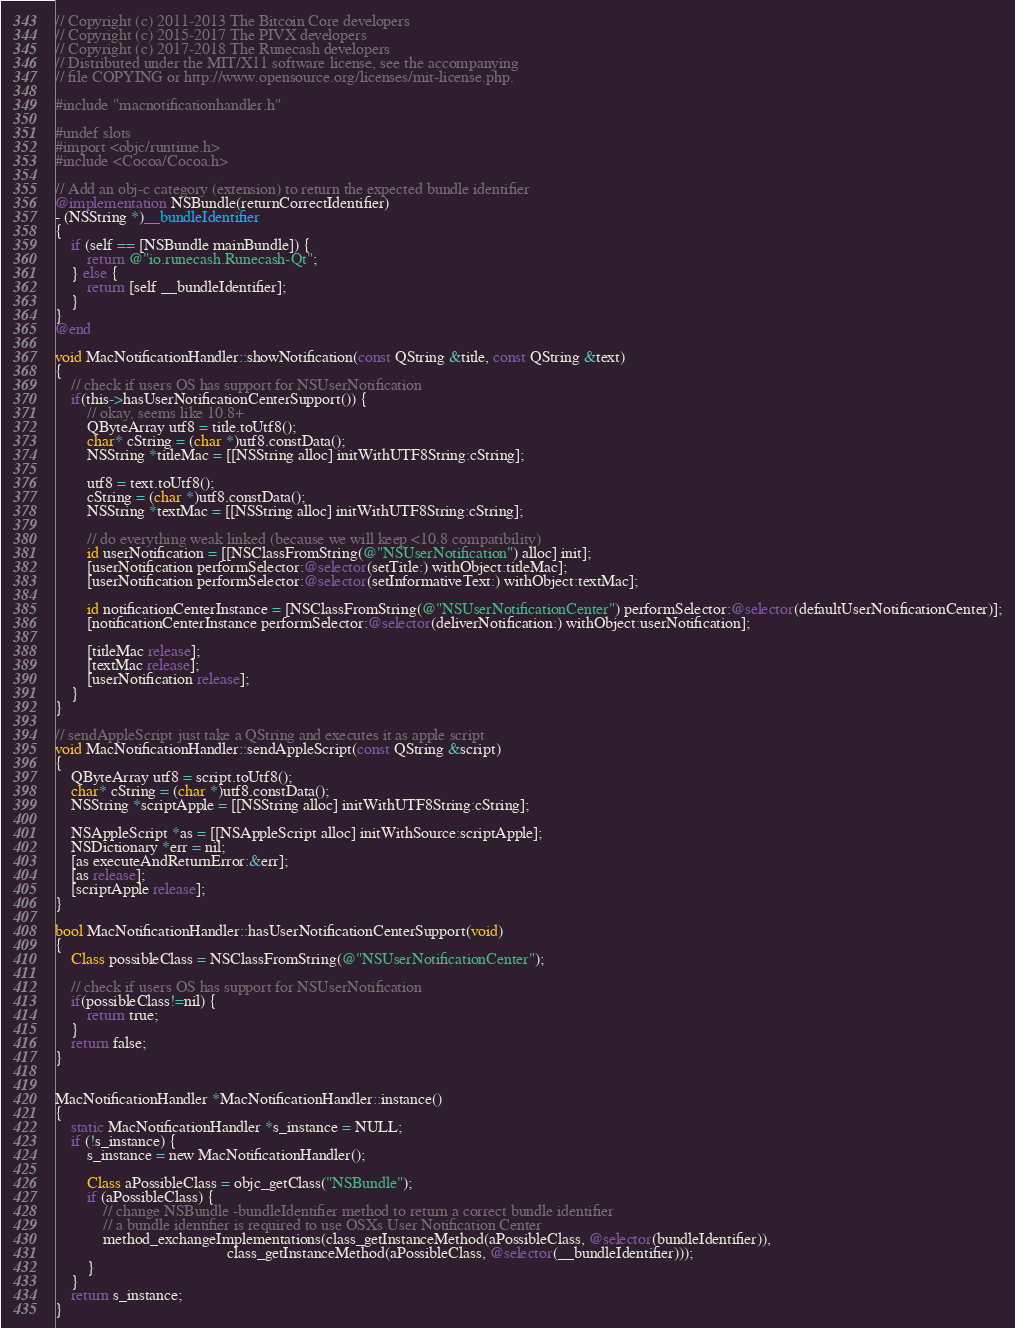<code> <loc_0><loc_0><loc_500><loc_500><_ObjectiveC_>// Copyright (c) 2011-2013 The Bitcoin Core developers
// Copyright (c) 2015-2017 The PIVX developers
// Copyright (c) 2017-2018 The Runecash developers
// Distributed under the MIT/X11 software license, see the accompanying
// file COPYING or http://www.opensource.org/licenses/mit-license.php.

#include "macnotificationhandler.h"

#undef slots
#import <objc/runtime.h>
#include <Cocoa/Cocoa.h>

// Add an obj-c category (extension) to return the expected bundle identifier
@implementation NSBundle(returnCorrectIdentifier)
- (NSString *)__bundleIdentifier
{
    if (self == [NSBundle mainBundle]) {
        return @"io.runecash.Runecash-Qt";
    } else {
        return [self __bundleIdentifier];
    }
}
@end

void MacNotificationHandler::showNotification(const QString &title, const QString &text)
{
    // check if users OS has support for NSUserNotification
    if(this->hasUserNotificationCenterSupport()) {
        // okay, seems like 10.8+
        QByteArray utf8 = title.toUtf8();
        char* cString = (char *)utf8.constData();
        NSString *titleMac = [[NSString alloc] initWithUTF8String:cString];

        utf8 = text.toUtf8();
        cString = (char *)utf8.constData();
        NSString *textMac = [[NSString alloc] initWithUTF8String:cString];

        // do everything weak linked (because we will keep <10.8 compatibility)
        id userNotification = [[NSClassFromString(@"NSUserNotification") alloc] init];
        [userNotification performSelector:@selector(setTitle:) withObject:titleMac];
        [userNotification performSelector:@selector(setInformativeText:) withObject:textMac];

        id notificationCenterInstance = [NSClassFromString(@"NSUserNotificationCenter") performSelector:@selector(defaultUserNotificationCenter)];
        [notificationCenterInstance performSelector:@selector(deliverNotification:) withObject:userNotification];

        [titleMac release];
        [textMac release];
        [userNotification release];
    }
}

// sendAppleScript just take a QString and executes it as apple script
void MacNotificationHandler::sendAppleScript(const QString &script)
{
    QByteArray utf8 = script.toUtf8();
    char* cString = (char *)utf8.constData();
    NSString *scriptApple = [[NSString alloc] initWithUTF8String:cString];

    NSAppleScript *as = [[NSAppleScript alloc] initWithSource:scriptApple];
    NSDictionary *err = nil;
    [as executeAndReturnError:&err];
    [as release];
    [scriptApple release];
}

bool MacNotificationHandler::hasUserNotificationCenterSupport(void)
{
    Class possibleClass = NSClassFromString(@"NSUserNotificationCenter");

    // check if users OS has support for NSUserNotification
    if(possibleClass!=nil) {
        return true;
    }
    return false;
}


MacNotificationHandler *MacNotificationHandler::instance()
{
    static MacNotificationHandler *s_instance = NULL;
    if (!s_instance) {
        s_instance = new MacNotificationHandler();
        
        Class aPossibleClass = objc_getClass("NSBundle");
        if (aPossibleClass) {
            // change NSBundle -bundleIdentifier method to return a correct bundle identifier
            // a bundle identifier is required to use OSXs User Notification Center
            method_exchangeImplementations(class_getInstanceMethod(aPossibleClass, @selector(bundleIdentifier)),
                                           class_getInstanceMethod(aPossibleClass, @selector(__bundleIdentifier)));
        }
    }
    return s_instance;
}
</code> 